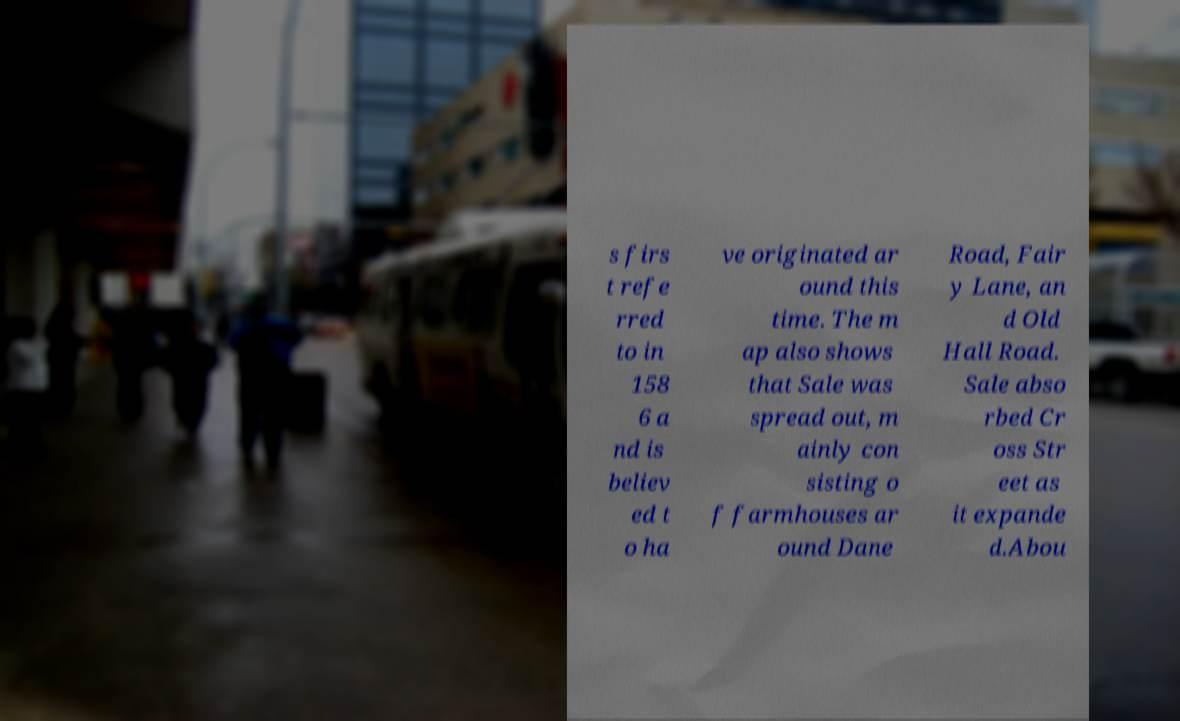Can you accurately transcribe the text from the provided image for me? s firs t refe rred to in 158 6 a nd is believ ed t o ha ve originated ar ound this time. The m ap also shows that Sale was spread out, m ainly con sisting o f farmhouses ar ound Dane Road, Fair y Lane, an d Old Hall Road. Sale abso rbed Cr oss Str eet as it expande d.Abou 